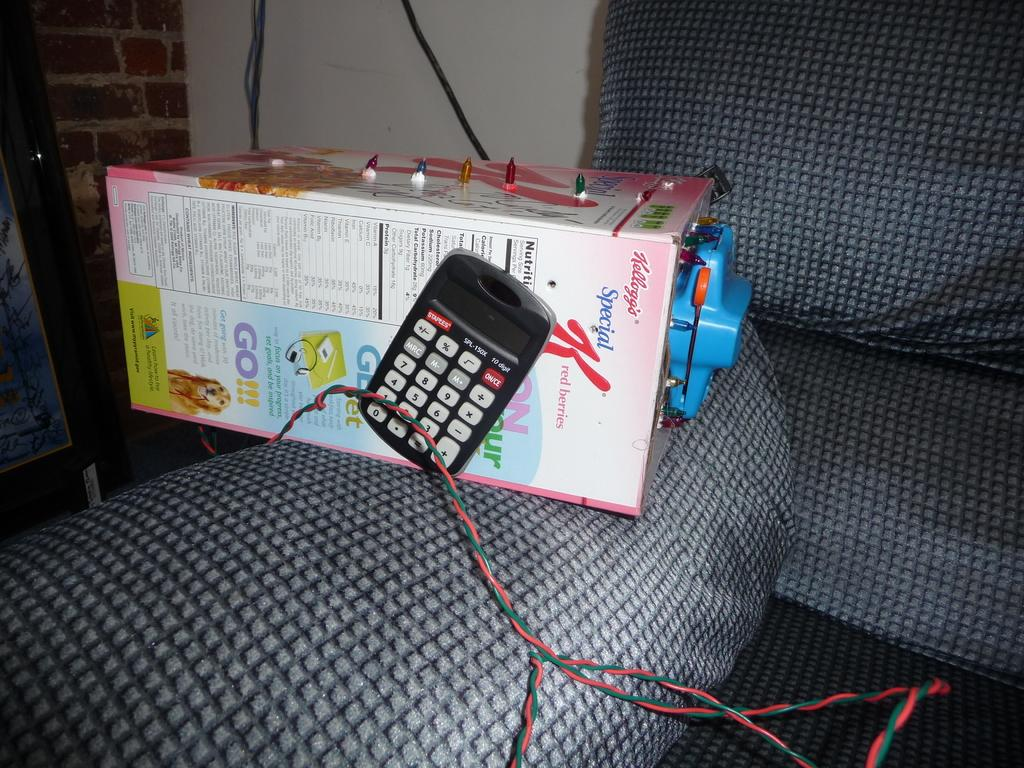<image>
Create a compact narrative representing the image presented. Box that says Kelloggs next to a calculator. 